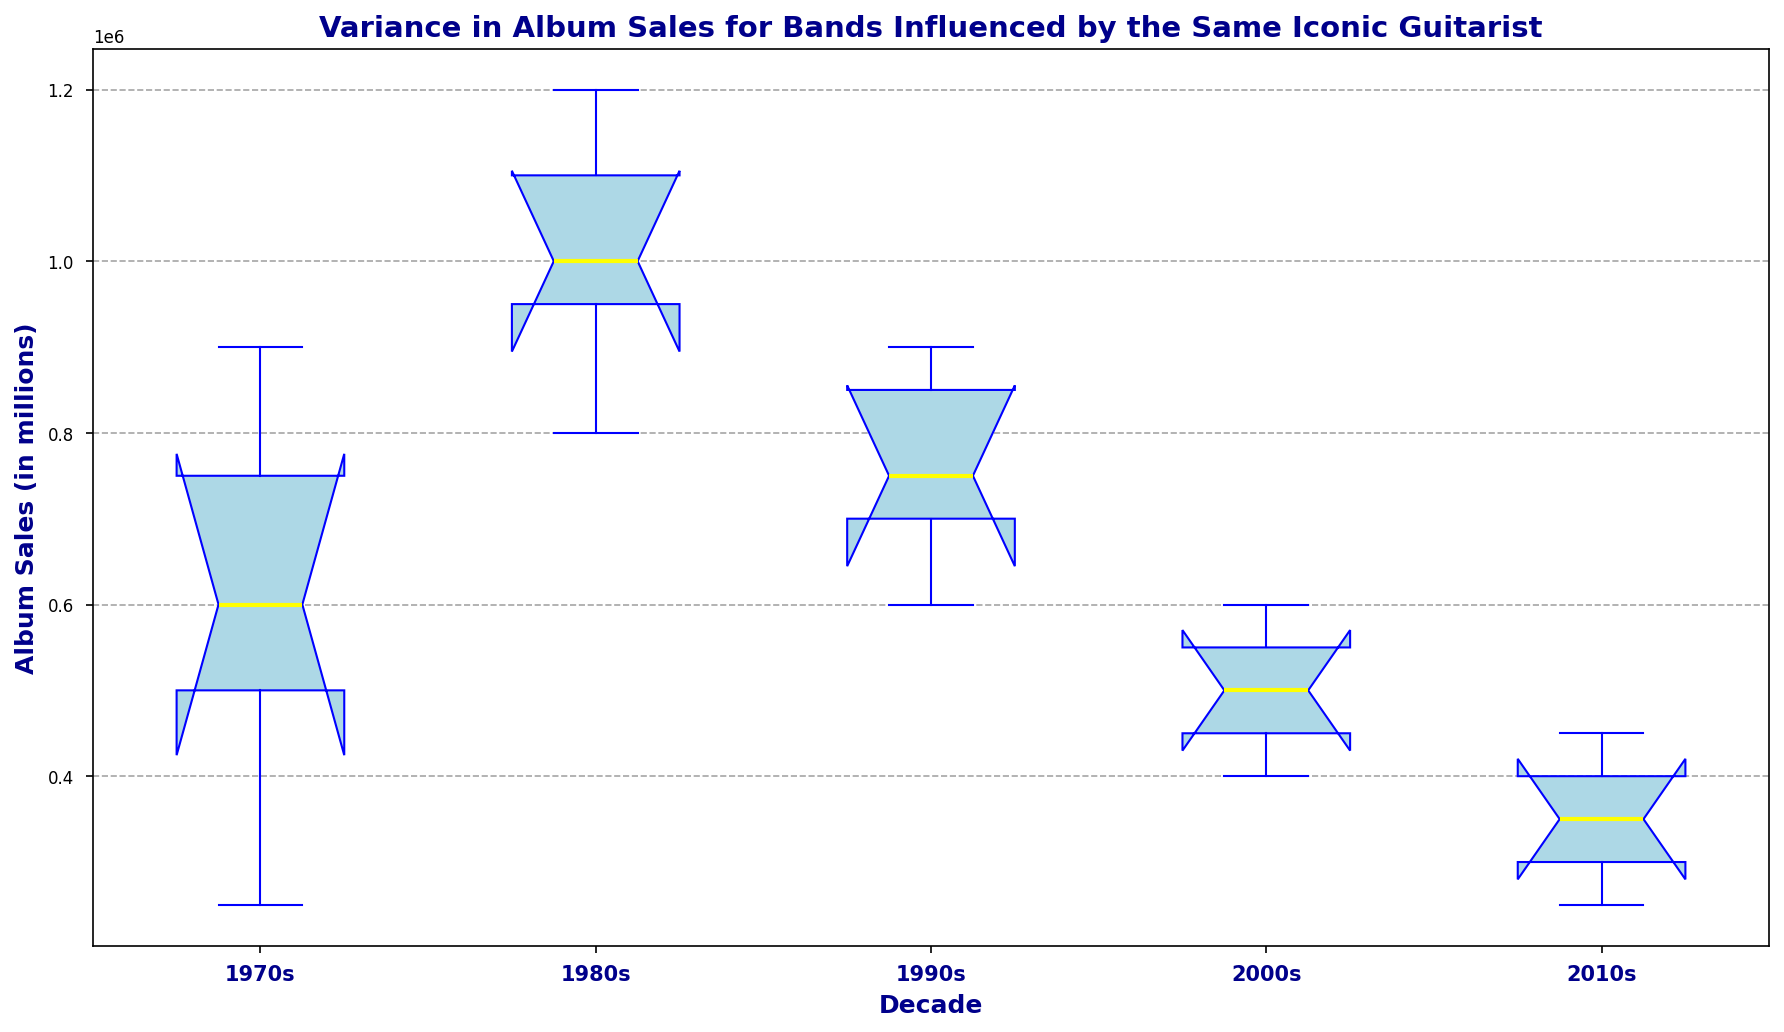Which decade shows the highest median album sales? To find the highest median album sales, we must look for the decade with the tallest median line (yellow) in the box plot.
Answer: 1980s How does the variance in album sales in the 2000s compare to the 1970s? Variance can be visually inferred by the length of the box and the spread of whiskers. The 2000s have a smaller range and shorter whiskers compared to the 1970s, indicating less variance.
Answer: 2000s have less variance than the 1970s Which decade experiences the lowest minimum album sales? The lowest minimum album sales will correspond to the lowest point of the lower whisker in the box plot.
Answer: 2010s What’s the difference between the median album sales of the 1980s and the 2010s? The median values can be identified by the yellow line in each box plot. For the 1980s, this line is at 1,000,000 units, and for the 2010s, it is at 350,000 units. The difference is 1,000,000 - 350,000.
Answer: 650,000 units Which decade has the highest spread between the upper and lower quartiles? The interquartile range (IQR) is the length of the box. The decade with the widest box has the highest IQR.
Answer: 1980s How do the outliers in the 1970s compare to those in the 2000s? Outliers are indicated by red markers outside the whiskers. The 1970s have one outlier around 900,000; the 2000s do not show any outliers.
Answer: 1970s have outliers, 2000s do not Which two decades have the closest median album sales? By comparing the yellow lines inside the boxes, the closest medians appear to be for the 1990s and the 2000s.
Answer: 1990s and 2000s If we sum the median sales of all decades, what is the total? Identifying the median sales for each decade: 1970s (600,000), 1980s (1,000,000), 1990s (750,000), 2000s (500,000), 2010s (350,000) and summing them up: 600,000 + 1,000,000 + 750,000 + 500,000 + 350,000.
Answer: 3,200,000 units 